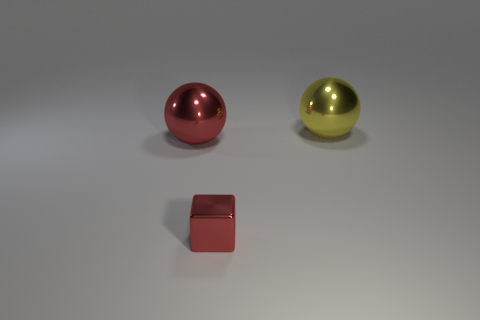Are there any other things that are the same color as the metal block?
Ensure brevity in your answer.  Yes. How many yellow shiny objects have the same shape as the large red object?
Your answer should be very brief. 1. What is the tiny red object made of?
Offer a very short reply. Metal. Is the number of yellow shiny things that are on the left side of the large yellow sphere the same as the number of small purple rubber spheres?
Ensure brevity in your answer.  Yes. Are there any red spheres in front of the large shiny thing that is to the right of the tiny red metallic thing?
Ensure brevity in your answer.  Yes. How many small objects are either yellow things or cyan cylinders?
Provide a short and direct response. 0. Is there a red metallic ball that has the same size as the yellow metal ball?
Ensure brevity in your answer.  Yes. How many metal things are either small blue cylinders or tiny red objects?
Give a very brief answer. 1. What is the shape of the shiny object that is the same color as the tiny shiny cube?
Provide a short and direct response. Sphere. How many red shiny balls are there?
Your response must be concise. 1. 